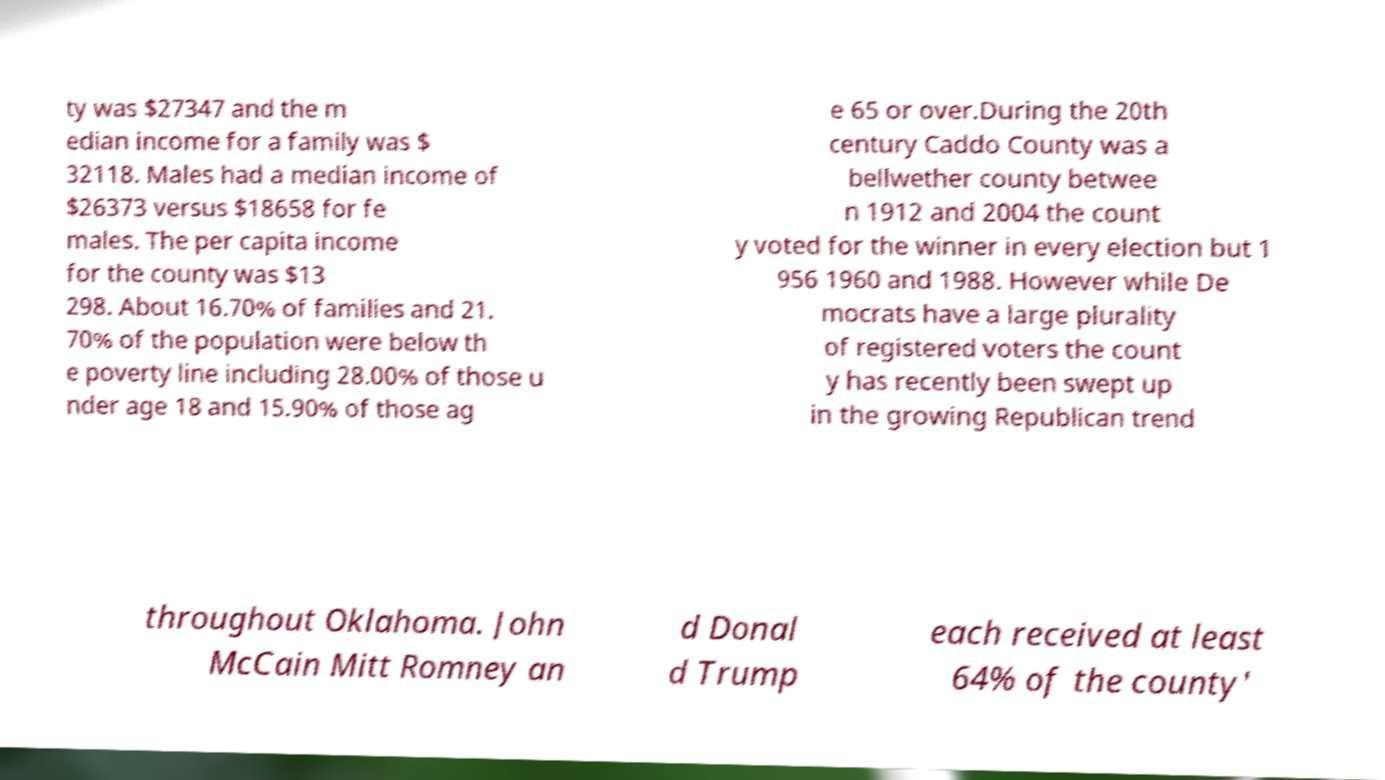Could you assist in decoding the text presented in this image and type it out clearly? ty was $27347 and the m edian income for a family was $ 32118. Males had a median income of $26373 versus $18658 for fe males. The per capita income for the county was $13 298. About 16.70% of families and 21. 70% of the population were below th e poverty line including 28.00% of those u nder age 18 and 15.90% of those ag e 65 or over.During the 20th century Caddo County was a bellwether county betwee n 1912 and 2004 the count y voted for the winner in every election but 1 956 1960 and 1988. However while De mocrats have a large plurality of registered voters the count y has recently been swept up in the growing Republican trend throughout Oklahoma. John McCain Mitt Romney an d Donal d Trump each received at least 64% of the county' 